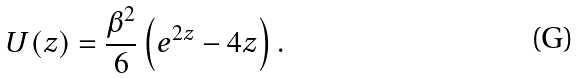<formula> <loc_0><loc_0><loc_500><loc_500>U ( z ) = \frac { \beta ^ { 2 } } { 6 } \left ( e ^ { 2 z } - 4 z \right ) .</formula> 